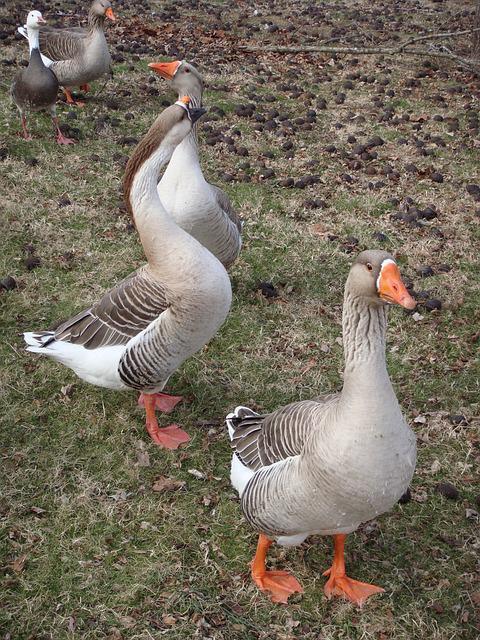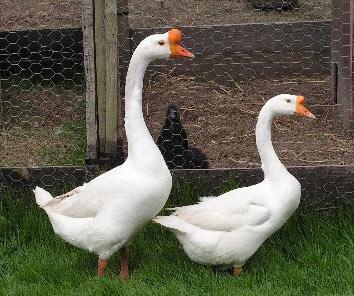The first image is the image on the left, the second image is the image on the right. For the images shown, is this caption "There are at least two animals in every image." true? Answer yes or no. Yes. 